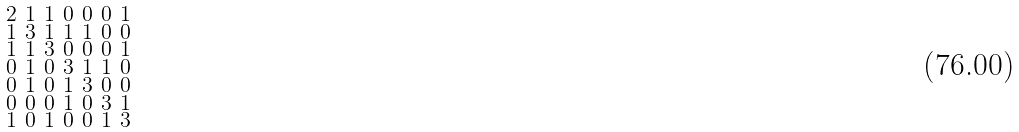<formula> <loc_0><loc_0><loc_500><loc_500>\begin{smallmatrix} 2 & 1 & 1 & 0 & 0 & 0 & 1 \\ 1 & 3 & 1 & 1 & 1 & 0 & 0 \\ 1 & 1 & 3 & 0 & 0 & 0 & 1 \\ 0 & 1 & 0 & 3 & 1 & 1 & 0 \\ 0 & 1 & 0 & 1 & 3 & 0 & 0 \\ 0 & 0 & 0 & 1 & 0 & 3 & 1 \\ 1 & 0 & 1 & 0 & 0 & 1 & 3 \end{smallmatrix}</formula> 